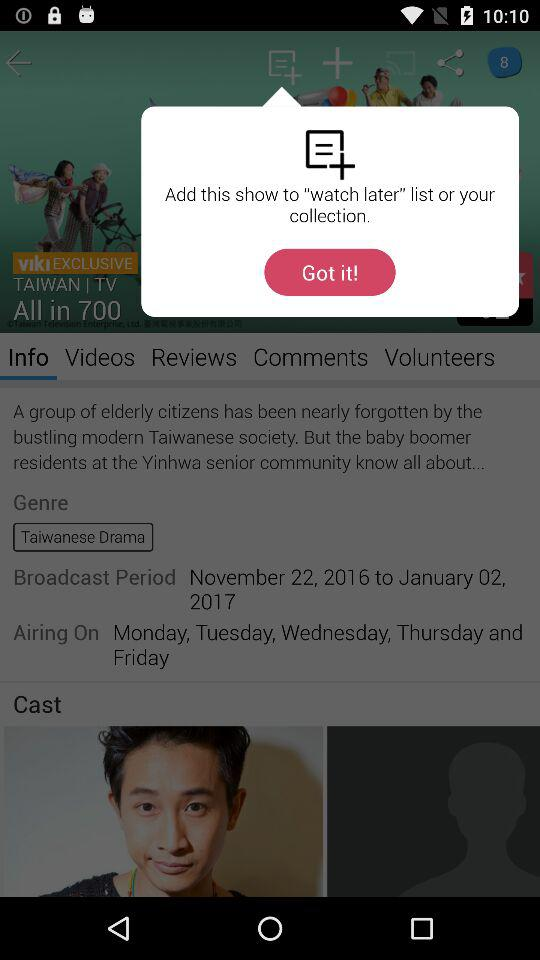What is the drama's airing schedule? The drama is scheduled to air from Monday to Friday. 